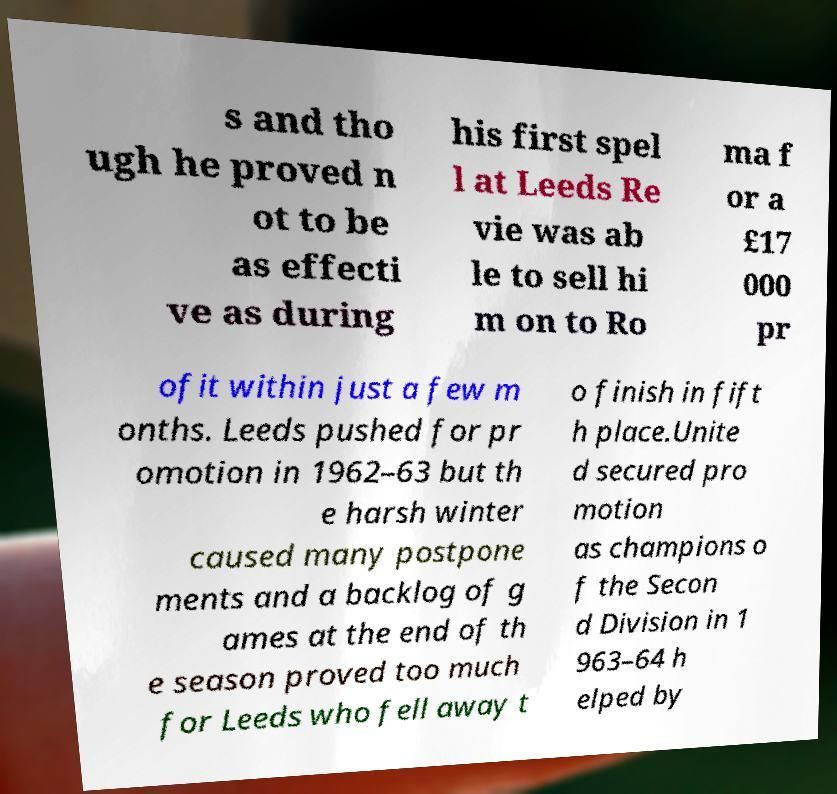Could you assist in decoding the text presented in this image and type it out clearly? s and tho ugh he proved n ot to be as effecti ve as during his first spel l at Leeds Re vie was ab le to sell hi m on to Ro ma f or a £17 000 pr ofit within just a few m onths. Leeds pushed for pr omotion in 1962–63 but th e harsh winter caused many postpone ments and a backlog of g ames at the end of th e season proved too much for Leeds who fell away t o finish in fift h place.Unite d secured pro motion as champions o f the Secon d Division in 1 963–64 h elped by 